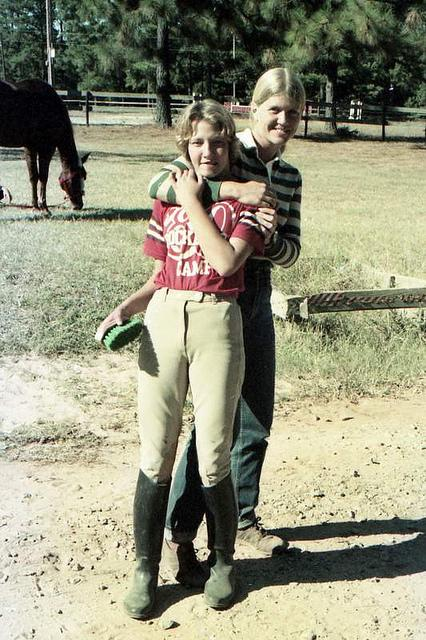What will she use the brush for? Please explain your reasoning. brush horse. There is a horse in the background. 